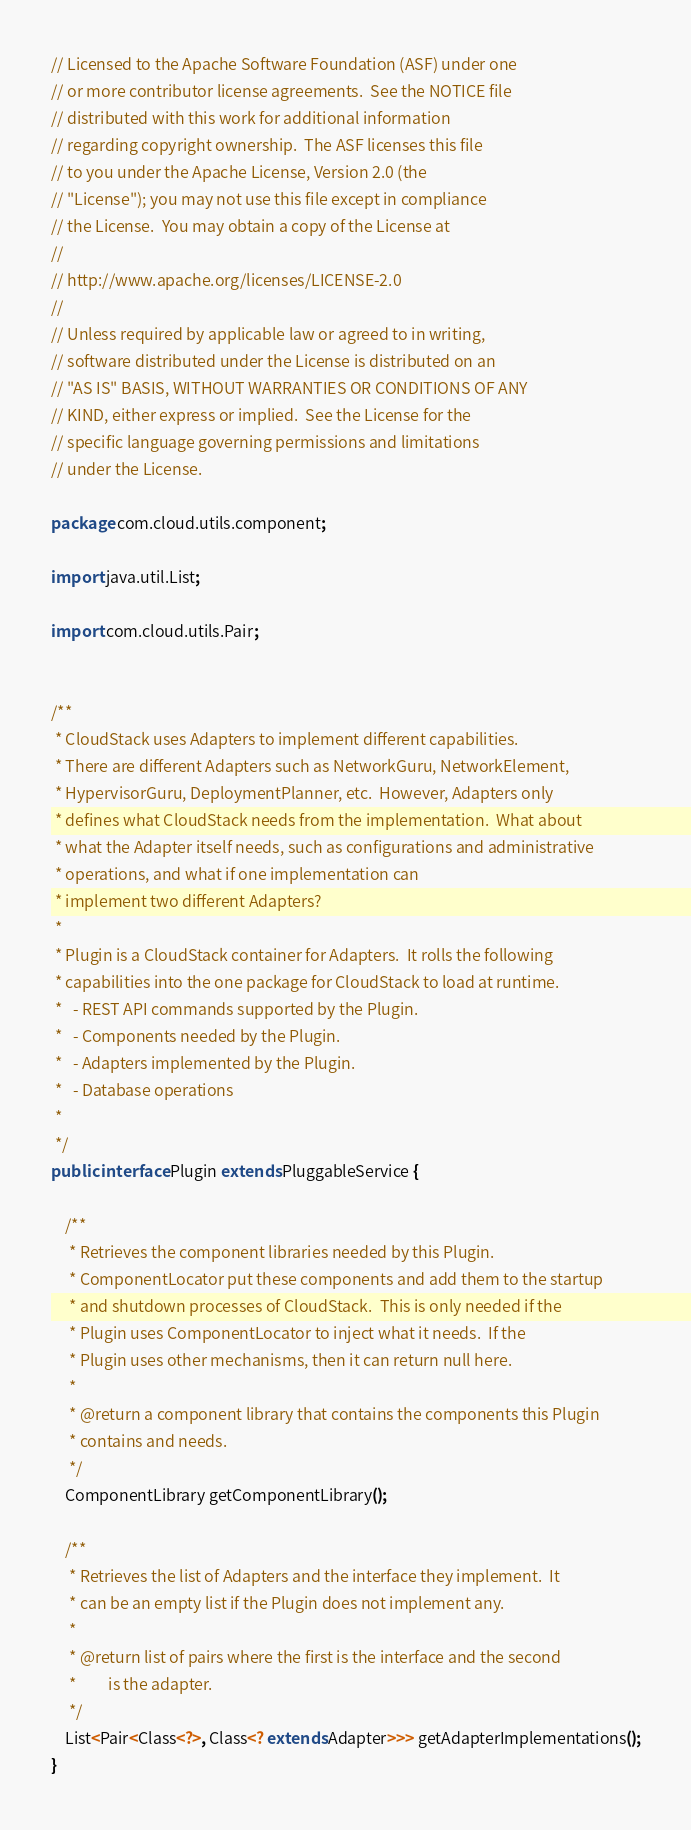Convert code to text. <code><loc_0><loc_0><loc_500><loc_500><_Java_>// Licensed to the Apache Software Foundation (ASF) under one
// or more contributor license agreements.  See the NOTICE file
// distributed with this work for additional information
// regarding copyright ownership.  The ASF licenses this file
// to you under the Apache License, Version 2.0 (the
// "License"); you may not use this file except in compliance
// the License.  You may obtain a copy of the License at
//
// http://www.apache.org/licenses/LICENSE-2.0
//
// Unless required by applicable law or agreed to in writing,
// software distributed under the License is distributed on an
// "AS IS" BASIS, WITHOUT WARRANTIES OR CONDITIONS OF ANY
// KIND, either express or implied.  See the License for the
// specific language governing permissions and limitations
// under the License.

package com.cloud.utils.component;

import java.util.List;

import com.cloud.utils.Pair;


/**
 * CloudStack uses Adapters to implement different capabilities.
 * There are different Adapters such as NetworkGuru, NetworkElement, 
 * HypervisorGuru, DeploymentPlanner, etc.  However, Adapters only
 * defines what CloudStack needs from the implementation.  What about
 * what the Adapter itself needs, such as configurations and administrative
 * operations, and what if one implementation can 
 * implement two different Adapters?
 *
 * Plugin is a CloudStack container for Adapters.  It rolls the following 
 * capabilities into the one package for CloudStack to load at runtime.
 *   - REST API commands supported by the Plugin.
 *   - Components needed by the Plugin.
 *   - Adapters implemented by the Plugin.
 *   - Database operations
 *
 */
public interface Plugin extends PluggableService {

    /**
     * Retrieves the component libraries needed by this Plugin.  
     * ComponentLocator put these components and add them to the startup 
     * and shutdown processes of CloudStack.  This is only needed if the 
     * Plugin uses ComponentLocator to inject what it needs.  If the
     * Plugin uses other mechanisms, then it can return null here.
     *  
     * @return a component library that contains the components this Plugin
     * contains and needs.
     */
    ComponentLibrary getComponentLibrary();

    /**
     * Retrieves the list of Adapters and the interface they implement.  It
     * can be an empty list if the Plugin does not implement any.
     * 
     * @return list of pairs where the first is the interface and the second 
     *         is the adapter.
     */
    List<Pair<Class<?>, Class<? extends Adapter>>> getAdapterImplementations();
}
</code> 